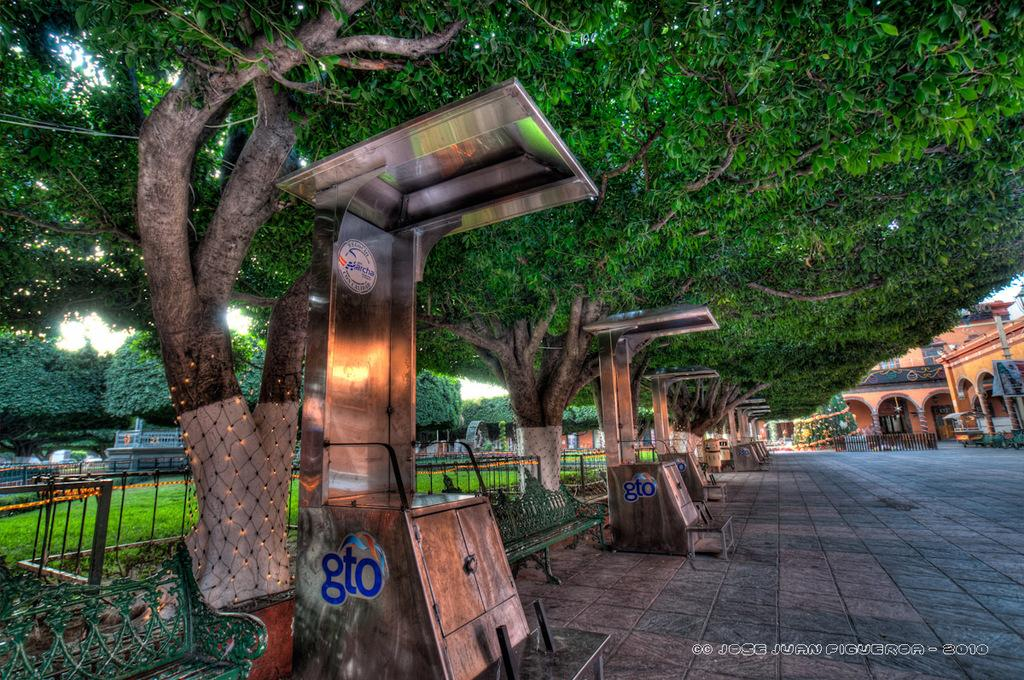What type of structures can be seen on the right side of the image? There are buildings on the right side of the image. What can be found on the left side of the image? There are benches on the left side of the image. What is visible in the background of the image? There is a rail, grass, and trees in the background of the image. What type of wool can be seen being copied by the cable in the image? There is no wool or cable present in the image. What type of copy machine is being used to duplicate the wool in the image? There is no copy machine or wool present in the image. 